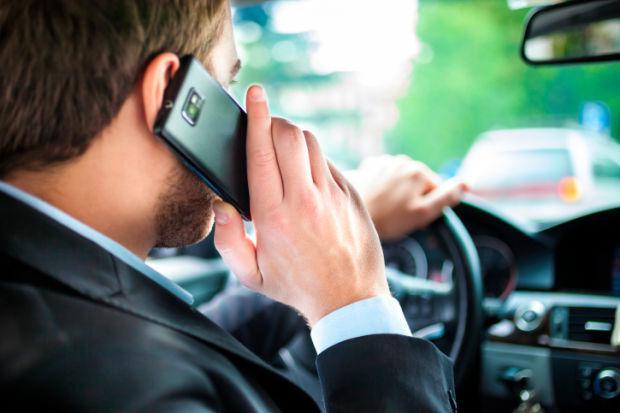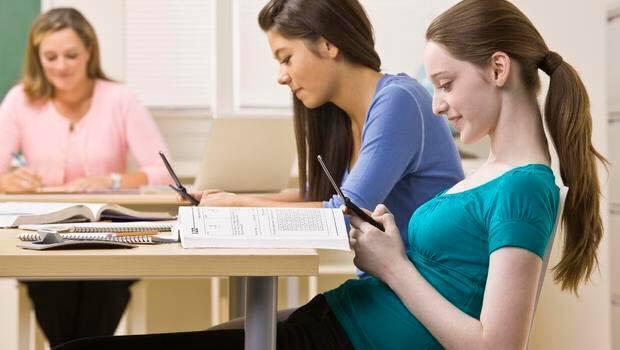The first image is the image on the left, the second image is the image on the right. Analyze the images presented: Is the assertion "A person is using a cell phone while in a car." valid? Answer yes or no. Yes. The first image is the image on the left, the second image is the image on the right. Given the left and right images, does the statement "A person is driving and holding a cell phone in the left image." hold true? Answer yes or no. Yes. 